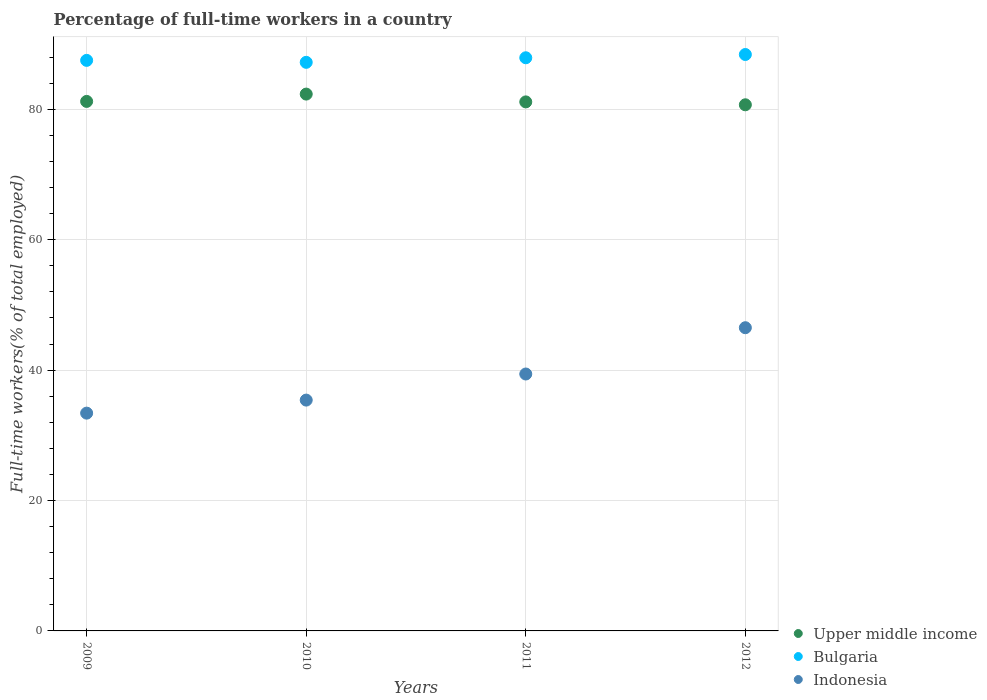How many different coloured dotlines are there?
Provide a short and direct response. 3. Is the number of dotlines equal to the number of legend labels?
Make the answer very short. Yes. What is the percentage of full-time workers in Upper middle income in 2009?
Your response must be concise. 81.21. Across all years, what is the maximum percentage of full-time workers in Indonesia?
Give a very brief answer. 46.5. Across all years, what is the minimum percentage of full-time workers in Bulgaria?
Your response must be concise. 87.2. In which year was the percentage of full-time workers in Upper middle income maximum?
Provide a succinct answer. 2010. In which year was the percentage of full-time workers in Bulgaria minimum?
Your answer should be very brief. 2010. What is the total percentage of full-time workers in Upper middle income in the graph?
Keep it short and to the point. 325.36. What is the difference between the percentage of full-time workers in Upper middle income in 2010 and that in 2012?
Provide a succinct answer. 1.64. What is the difference between the percentage of full-time workers in Upper middle income in 2012 and the percentage of full-time workers in Bulgaria in 2009?
Provide a succinct answer. -6.81. What is the average percentage of full-time workers in Indonesia per year?
Ensure brevity in your answer.  38.68. In the year 2010, what is the difference between the percentage of full-time workers in Indonesia and percentage of full-time workers in Bulgaria?
Provide a short and direct response. -51.8. What is the ratio of the percentage of full-time workers in Bulgaria in 2011 to that in 2012?
Give a very brief answer. 0.99. Is the difference between the percentage of full-time workers in Indonesia in 2011 and 2012 greater than the difference between the percentage of full-time workers in Bulgaria in 2011 and 2012?
Provide a succinct answer. No. What is the difference between the highest and the second highest percentage of full-time workers in Indonesia?
Your response must be concise. 7.1. What is the difference between the highest and the lowest percentage of full-time workers in Indonesia?
Provide a short and direct response. 13.1. Does the percentage of full-time workers in Bulgaria monotonically increase over the years?
Offer a terse response. No. Is the percentage of full-time workers in Upper middle income strictly less than the percentage of full-time workers in Indonesia over the years?
Provide a short and direct response. No. Are the values on the major ticks of Y-axis written in scientific E-notation?
Your response must be concise. No. How are the legend labels stacked?
Ensure brevity in your answer.  Vertical. What is the title of the graph?
Your answer should be very brief. Percentage of full-time workers in a country. Does "Dominica" appear as one of the legend labels in the graph?
Provide a succinct answer. No. What is the label or title of the Y-axis?
Your answer should be very brief. Full-time workers(% of total employed). What is the Full-time workers(% of total employed) of Upper middle income in 2009?
Give a very brief answer. 81.21. What is the Full-time workers(% of total employed) in Bulgaria in 2009?
Provide a succinct answer. 87.5. What is the Full-time workers(% of total employed) in Indonesia in 2009?
Your answer should be very brief. 33.4. What is the Full-time workers(% of total employed) of Upper middle income in 2010?
Offer a very short reply. 82.33. What is the Full-time workers(% of total employed) of Bulgaria in 2010?
Provide a short and direct response. 87.2. What is the Full-time workers(% of total employed) in Indonesia in 2010?
Your response must be concise. 35.4. What is the Full-time workers(% of total employed) of Upper middle income in 2011?
Make the answer very short. 81.13. What is the Full-time workers(% of total employed) of Bulgaria in 2011?
Provide a short and direct response. 87.9. What is the Full-time workers(% of total employed) of Indonesia in 2011?
Provide a succinct answer. 39.4. What is the Full-time workers(% of total employed) in Upper middle income in 2012?
Your answer should be very brief. 80.69. What is the Full-time workers(% of total employed) of Bulgaria in 2012?
Give a very brief answer. 88.4. What is the Full-time workers(% of total employed) of Indonesia in 2012?
Keep it short and to the point. 46.5. Across all years, what is the maximum Full-time workers(% of total employed) of Upper middle income?
Provide a succinct answer. 82.33. Across all years, what is the maximum Full-time workers(% of total employed) in Bulgaria?
Your answer should be very brief. 88.4. Across all years, what is the maximum Full-time workers(% of total employed) of Indonesia?
Offer a terse response. 46.5. Across all years, what is the minimum Full-time workers(% of total employed) in Upper middle income?
Keep it short and to the point. 80.69. Across all years, what is the minimum Full-time workers(% of total employed) of Bulgaria?
Give a very brief answer. 87.2. Across all years, what is the minimum Full-time workers(% of total employed) in Indonesia?
Your answer should be compact. 33.4. What is the total Full-time workers(% of total employed) of Upper middle income in the graph?
Provide a succinct answer. 325.36. What is the total Full-time workers(% of total employed) in Bulgaria in the graph?
Offer a very short reply. 351. What is the total Full-time workers(% of total employed) of Indonesia in the graph?
Keep it short and to the point. 154.7. What is the difference between the Full-time workers(% of total employed) in Upper middle income in 2009 and that in 2010?
Provide a succinct answer. -1.12. What is the difference between the Full-time workers(% of total employed) of Indonesia in 2009 and that in 2010?
Provide a short and direct response. -2. What is the difference between the Full-time workers(% of total employed) of Upper middle income in 2009 and that in 2011?
Your response must be concise. 0.07. What is the difference between the Full-time workers(% of total employed) in Bulgaria in 2009 and that in 2011?
Give a very brief answer. -0.4. What is the difference between the Full-time workers(% of total employed) of Indonesia in 2009 and that in 2011?
Your answer should be compact. -6. What is the difference between the Full-time workers(% of total employed) of Upper middle income in 2009 and that in 2012?
Offer a very short reply. 0.52. What is the difference between the Full-time workers(% of total employed) in Bulgaria in 2009 and that in 2012?
Provide a succinct answer. -0.9. What is the difference between the Full-time workers(% of total employed) in Upper middle income in 2010 and that in 2011?
Your answer should be very brief. 1.2. What is the difference between the Full-time workers(% of total employed) in Bulgaria in 2010 and that in 2011?
Your response must be concise. -0.7. What is the difference between the Full-time workers(% of total employed) in Upper middle income in 2010 and that in 2012?
Offer a terse response. 1.64. What is the difference between the Full-time workers(% of total employed) in Indonesia in 2010 and that in 2012?
Ensure brevity in your answer.  -11.1. What is the difference between the Full-time workers(% of total employed) of Upper middle income in 2011 and that in 2012?
Keep it short and to the point. 0.44. What is the difference between the Full-time workers(% of total employed) of Bulgaria in 2011 and that in 2012?
Give a very brief answer. -0.5. What is the difference between the Full-time workers(% of total employed) of Indonesia in 2011 and that in 2012?
Offer a terse response. -7.1. What is the difference between the Full-time workers(% of total employed) in Upper middle income in 2009 and the Full-time workers(% of total employed) in Bulgaria in 2010?
Ensure brevity in your answer.  -5.99. What is the difference between the Full-time workers(% of total employed) in Upper middle income in 2009 and the Full-time workers(% of total employed) in Indonesia in 2010?
Provide a succinct answer. 45.81. What is the difference between the Full-time workers(% of total employed) in Bulgaria in 2009 and the Full-time workers(% of total employed) in Indonesia in 2010?
Make the answer very short. 52.1. What is the difference between the Full-time workers(% of total employed) in Upper middle income in 2009 and the Full-time workers(% of total employed) in Bulgaria in 2011?
Provide a short and direct response. -6.69. What is the difference between the Full-time workers(% of total employed) in Upper middle income in 2009 and the Full-time workers(% of total employed) in Indonesia in 2011?
Offer a terse response. 41.81. What is the difference between the Full-time workers(% of total employed) in Bulgaria in 2009 and the Full-time workers(% of total employed) in Indonesia in 2011?
Make the answer very short. 48.1. What is the difference between the Full-time workers(% of total employed) of Upper middle income in 2009 and the Full-time workers(% of total employed) of Bulgaria in 2012?
Offer a very short reply. -7.19. What is the difference between the Full-time workers(% of total employed) in Upper middle income in 2009 and the Full-time workers(% of total employed) in Indonesia in 2012?
Provide a short and direct response. 34.71. What is the difference between the Full-time workers(% of total employed) of Upper middle income in 2010 and the Full-time workers(% of total employed) of Bulgaria in 2011?
Offer a terse response. -5.57. What is the difference between the Full-time workers(% of total employed) in Upper middle income in 2010 and the Full-time workers(% of total employed) in Indonesia in 2011?
Keep it short and to the point. 42.93. What is the difference between the Full-time workers(% of total employed) of Bulgaria in 2010 and the Full-time workers(% of total employed) of Indonesia in 2011?
Your answer should be compact. 47.8. What is the difference between the Full-time workers(% of total employed) in Upper middle income in 2010 and the Full-time workers(% of total employed) in Bulgaria in 2012?
Offer a terse response. -6.07. What is the difference between the Full-time workers(% of total employed) in Upper middle income in 2010 and the Full-time workers(% of total employed) in Indonesia in 2012?
Offer a terse response. 35.83. What is the difference between the Full-time workers(% of total employed) of Bulgaria in 2010 and the Full-time workers(% of total employed) of Indonesia in 2012?
Make the answer very short. 40.7. What is the difference between the Full-time workers(% of total employed) of Upper middle income in 2011 and the Full-time workers(% of total employed) of Bulgaria in 2012?
Offer a terse response. -7.27. What is the difference between the Full-time workers(% of total employed) of Upper middle income in 2011 and the Full-time workers(% of total employed) of Indonesia in 2012?
Provide a short and direct response. 34.63. What is the difference between the Full-time workers(% of total employed) in Bulgaria in 2011 and the Full-time workers(% of total employed) in Indonesia in 2012?
Provide a succinct answer. 41.4. What is the average Full-time workers(% of total employed) of Upper middle income per year?
Offer a terse response. 81.34. What is the average Full-time workers(% of total employed) of Bulgaria per year?
Offer a terse response. 87.75. What is the average Full-time workers(% of total employed) in Indonesia per year?
Provide a succinct answer. 38.67. In the year 2009, what is the difference between the Full-time workers(% of total employed) in Upper middle income and Full-time workers(% of total employed) in Bulgaria?
Offer a very short reply. -6.29. In the year 2009, what is the difference between the Full-time workers(% of total employed) of Upper middle income and Full-time workers(% of total employed) of Indonesia?
Your answer should be compact. 47.81. In the year 2009, what is the difference between the Full-time workers(% of total employed) of Bulgaria and Full-time workers(% of total employed) of Indonesia?
Offer a terse response. 54.1. In the year 2010, what is the difference between the Full-time workers(% of total employed) in Upper middle income and Full-time workers(% of total employed) in Bulgaria?
Your answer should be compact. -4.87. In the year 2010, what is the difference between the Full-time workers(% of total employed) of Upper middle income and Full-time workers(% of total employed) of Indonesia?
Offer a very short reply. 46.93. In the year 2010, what is the difference between the Full-time workers(% of total employed) of Bulgaria and Full-time workers(% of total employed) of Indonesia?
Keep it short and to the point. 51.8. In the year 2011, what is the difference between the Full-time workers(% of total employed) in Upper middle income and Full-time workers(% of total employed) in Bulgaria?
Your response must be concise. -6.77. In the year 2011, what is the difference between the Full-time workers(% of total employed) in Upper middle income and Full-time workers(% of total employed) in Indonesia?
Provide a succinct answer. 41.73. In the year 2011, what is the difference between the Full-time workers(% of total employed) in Bulgaria and Full-time workers(% of total employed) in Indonesia?
Provide a short and direct response. 48.5. In the year 2012, what is the difference between the Full-time workers(% of total employed) in Upper middle income and Full-time workers(% of total employed) in Bulgaria?
Give a very brief answer. -7.71. In the year 2012, what is the difference between the Full-time workers(% of total employed) in Upper middle income and Full-time workers(% of total employed) in Indonesia?
Provide a short and direct response. 34.19. In the year 2012, what is the difference between the Full-time workers(% of total employed) in Bulgaria and Full-time workers(% of total employed) in Indonesia?
Keep it short and to the point. 41.9. What is the ratio of the Full-time workers(% of total employed) in Upper middle income in 2009 to that in 2010?
Your answer should be compact. 0.99. What is the ratio of the Full-time workers(% of total employed) of Bulgaria in 2009 to that in 2010?
Offer a very short reply. 1. What is the ratio of the Full-time workers(% of total employed) in Indonesia in 2009 to that in 2010?
Provide a short and direct response. 0.94. What is the ratio of the Full-time workers(% of total employed) in Upper middle income in 2009 to that in 2011?
Make the answer very short. 1. What is the ratio of the Full-time workers(% of total employed) of Bulgaria in 2009 to that in 2011?
Provide a short and direct response. 1. What is the ratio of the Full-time workers(% of total employed) of Indonesia in 2009 to that in 2011?
Make the answer very short. 0.85. What is the ratio of the Full-time workers(% of total employed) in Upper middle income in 2009 to that in 2012?
Your response must be concise. 1.01. What is the ratio of the Full-time workers(% of total employed) of Bulgaria in 2009 to that in 2012?
Make the answer very short. 0.99. What is the ratio of the Full-time workers(% of total employed) of Indonesia in 2009 to that in 2012?
Keep it short and to the point. 0.72. What is the ratio of the Full-time workers(% of total employed) of Upper middle income in 2010 to that in 2011?
Your answer should be compact. 1.01. What is the ratio of the Full-time workers(% of total employed) in Indonesia in 2010 to that in 2011?
Your response must be concise. 0.9. What is the ratio of the Full-time workers(% of total employed) of Upper middle income in 2010 to that in 2012?
Your answer should be very brief. 1.02. What is the ratio of the Full-time workers(% of total employed) of Bulgaria in 2010 to that in 2012?
Your answer should be very brief. 0.99. What is the ratio of the Full-time workers(% of total employed) in Indonesia in 2010 to that in 2012?
Your answer should be very brief. 0.76. What is the ratio of the Full-time workers(% of total employed) in Upper middle income in 2011 to that in 2012?
Provide a succinct answer. 1.01. What is the ratio of the Full-time workers(% of total employed) in Indonesia in 2011 to that in 2012?
Your answer should be compact. 0.85. What is the difference between the highest and the second highest Full-time workers(% of total employed) of Upper middle income?
Keep it short and to the point. 1.12. What is the difference between the highest and the second highest Full-time workers(% of total employed) in Bulgaria?
Provide a short and direct response. 0.5. What is the difference between the highest and the second highest Full-time workers(% of total employed) in Indonesia?
Your answer should be very brief. 7.1. What is the difference between the highest and the lowest Full-time workers(% of total employed) in Upper middle income?
Your answer should be compact. 1.64. 